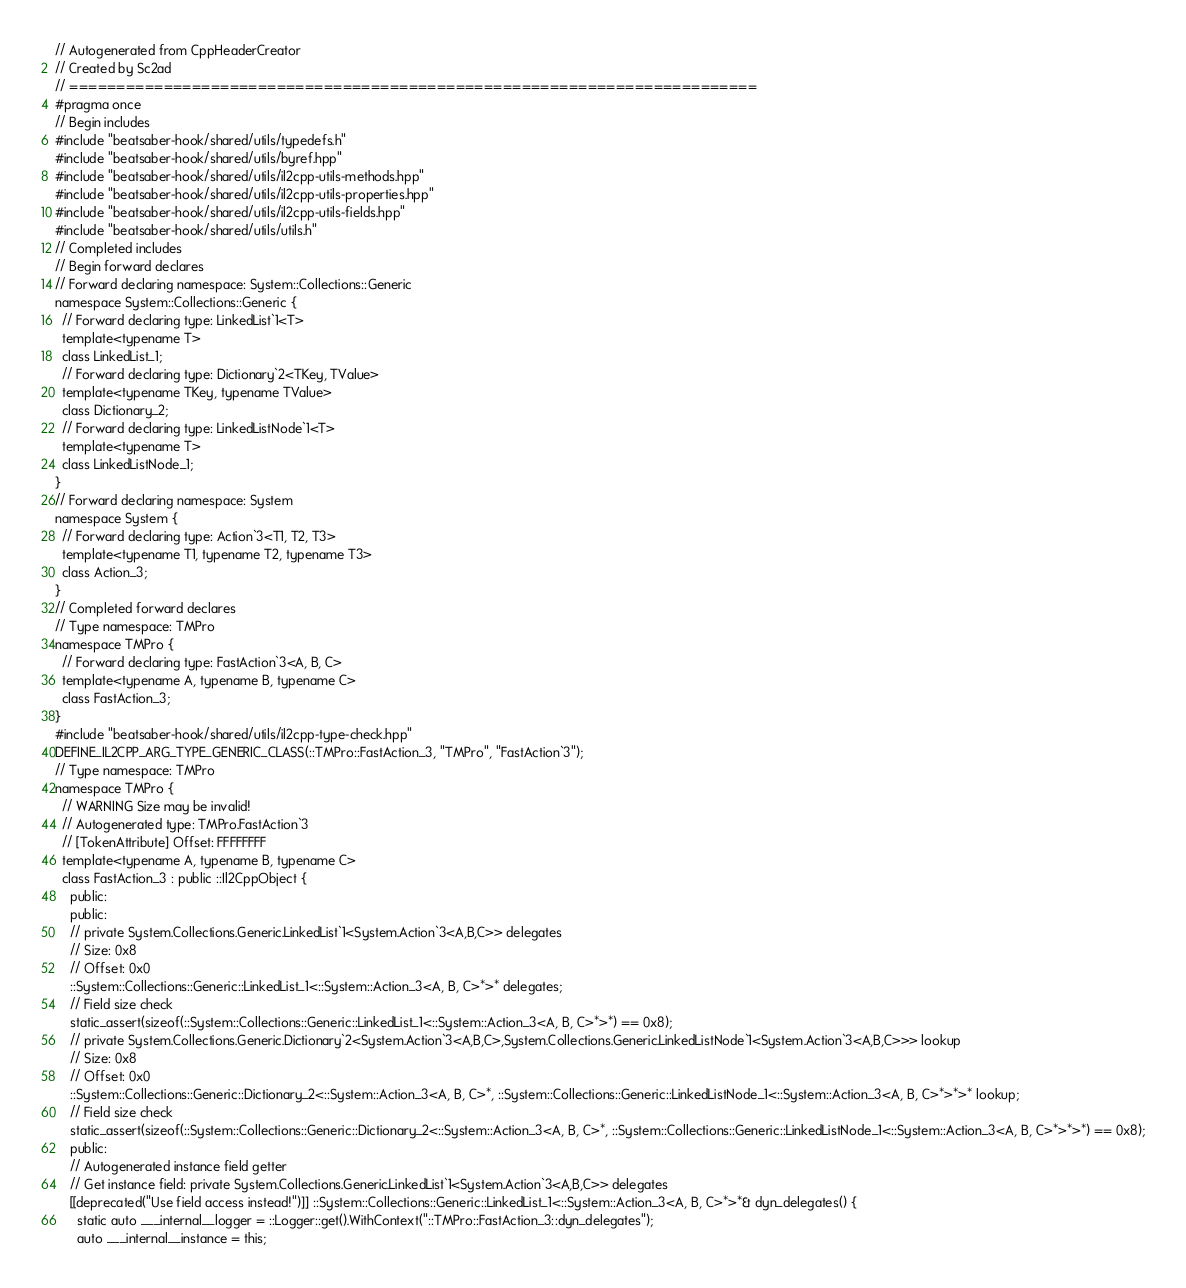Convert code to text. <code><loc_0><loc_0><loc_500><loc_500><_C++_>// Autogenerated from CppHeaderCreator
// Created by Sc2ad
// =========================================================================
#pragma once
// Begin includes
#include "beatsaber-hook/shared/utils/typedefs.h"
#include "beatsaber-hook/shared/utils/byref.hpp"
#include "beatsaber-hook/shared/utils/il2cpp-utils-methods.hpp"
#include "beatsaber-hook/shared/utils/il2cpp-utils-properties.hpp"
#include "beatsaber-hook/shared/utils/il2cpp-utils-fields.hpp"
#include "beatsaber-hook/shared/utils/utils.h"
// Completed includes
// Begin forward declares
// Forward declaring namespace: System::Collections::Generic
namespace System::Collections::Generic {
  // Forward declaring type: LinkedList`1<T>
  template<typename T>
  class LinkedList_1;
  // Forward declaring type: Dictionary`2<TKey, TValue>
  template<typename TKey, typename TValue>
  class Dictionary_2;
  // Forward declaring type: LinkedListNode`1<T>
  template<typename T>
  class LinkedListNode_1;
}
// Forward declaring namespace: System
namespace System {
  // Forward declaring type: Action`3<T1, T2, T3>
  template<typename T1, typename T2, typename T3>
  class Action_3;
}
// Completed forward declares
// Type namespace: TMPro
namespace TMPro {
  // Forward declaring type: FastAction`3<A, B, C>
  template<typename A, typename B, typename C>
  class FastAction_3;
}
#include "beatsaber-hook/shared/utils/il2cpp-type-check.hpp"
DEFINE_IL2CPP_ARG_TYPE_GENERIC_CLASS(::TMPro::FastAction_3, "TMPro", "FastAction`3");
// Type namespace: TMPro
namespace TMPro {
  // WARNING Size may be invalid!
  // Autogenerated type: TMPro.FastAction`3
  // [TokenAttribute] Offset: FFFFFFFF
  template<typename A, typename B, typename C>
  class FastAction_3 : public ::Il2CppObject {
    public:
    public:
    // private System.Collections.Generic.LinkedList`1<System.Action`3<A,B,C>> delegates
    // Size: 0x8
    // Offset: 0x0
    ::System::Collections::Generic::LinkedList_1<::System::Action_3<A, B, C>*>* delegates;
    // Field size check
    static_assert(sizeof(::System::Collections::Generic::LinkedList_1<::System::Action_3<A, B, C>*>*) == 0x8);
    // private System.Collections.Generic.Dictionary`2<System.Action`3<A,B,C>,System.Collections.Generic.LinkedListNode`1<System.Action`3<A,B,C>>> lookup
    // Size: 0x8
    // Offset: 0x0
    ::System::Collections::Generic::Dictionary_2<::System::Action_3<A, B, C>*, ::System::Collections::Generic::LinkedListNode_1<::System::Action_3<A, B, C>*>*>* lookup;
    // Field size check
    static_assert(sizeof(::System::Collections::Generic::Dictionary_2<::System::Action_3<A, B, C>*, ::System::Collections::Generic::LinkedListNode_1<::System::Action_3<A, B, C>*>*>*) == 0x8);
    public:
    // Autogenerated instance field getter
    // Get instance field: private System.Collections.Generic.LinkedList`1<System.Action`3<A,B,C>> delegates
    [[deprecated("Use field access instead!")]] ::System::Collections::Generic::LinkedList_1<::System::Action_3<A, B, C>*>*& dyn_delegates() {
      static auto ___internal__logger = ::Logger::get().WithContext("::TMPro::FastAction_3::dyn_delegates");
      auto ___internal__instance = this;</code> 